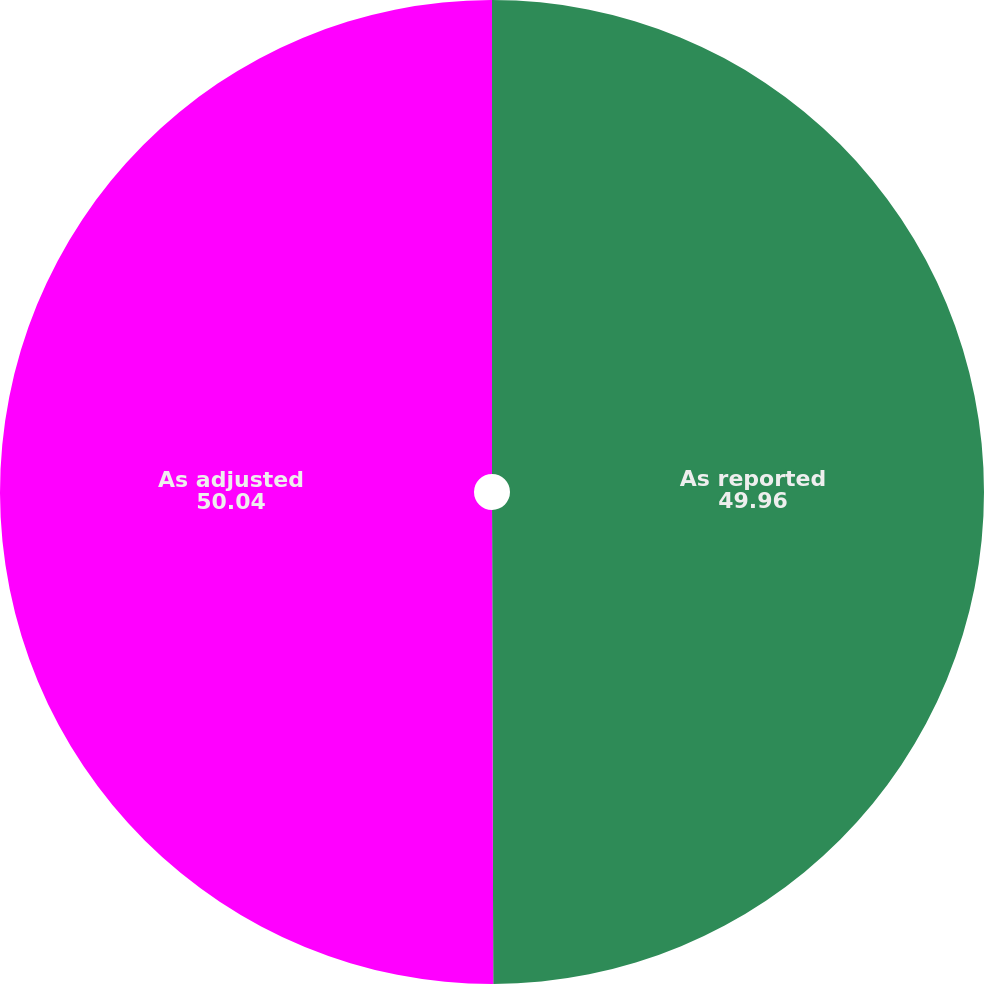Convert chart. <chart><loc_0><loc_0><loc_500><loc_500><pie_chart><fcel>As reported<fcel>As adjusted<nl><fcel>49.96%<fcel>50.04%<nl></chart> 